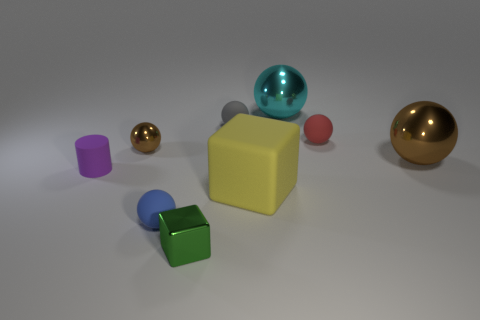Subtract 2 balls. How many balls are left? 4 Subtract all brown metallic balls. How many balls are left? 4 Subtract all cyan balls. How many balls are left? 5 Subtract all purple spheres. Subtract all green blocks. How many spheres are left? 6 Subtract all balls. How many objects are left? 3 Subtract all large purple cylinders. Subtract all small metallic balls. How many objects are left? 8 Add 8 tiny brown metallic balls. How many tiny brown metallic balls are left? 9 Add 7 tiny green shiny objects. How many tiny green shiny objects exist? 8 Subtract 1 gray spheres. How many objects are left? 8 